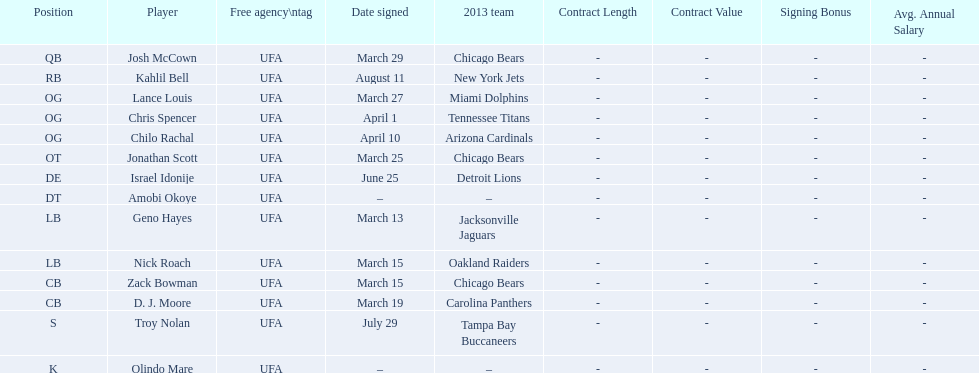Geno hayes and nick roach both played which position? LB. 